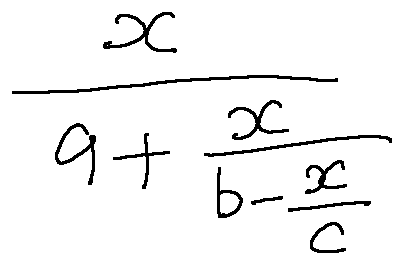Convert formula to latex. <formula><loc_0><loc_0><loc_500><loc_500>\frac { x } { a + \frac { x } { b - \frac { x } { c } } }</formula> 